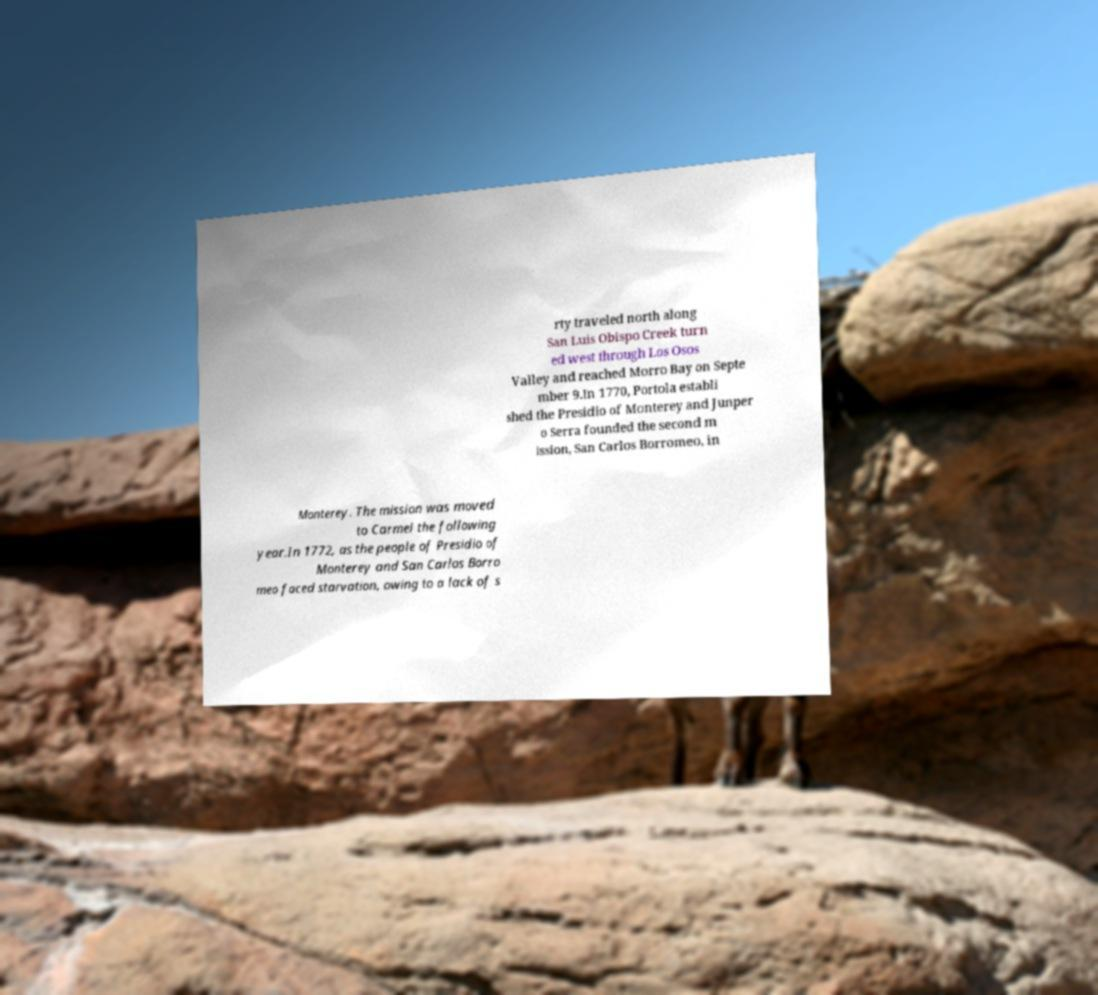Can you read and provide the text displayed in the image?This photo seems to have some interesting text. Can you extract and type it out for me? rty traveled north along San Luis Obispo Creek turn ed west through Los Osos Valley and reached Morro Bay on Septe mber 9.In 1770, Portola establi shed the Presidio of Monterey and Junper o Serra founded the second m ission, San Carlos Borromeo, in Monterey. The mission was moved to Carmel the following year.In 1772, as the people of Presidio of Monterey and San Carlos Borro meo faced starvation, owing to a lack of s 